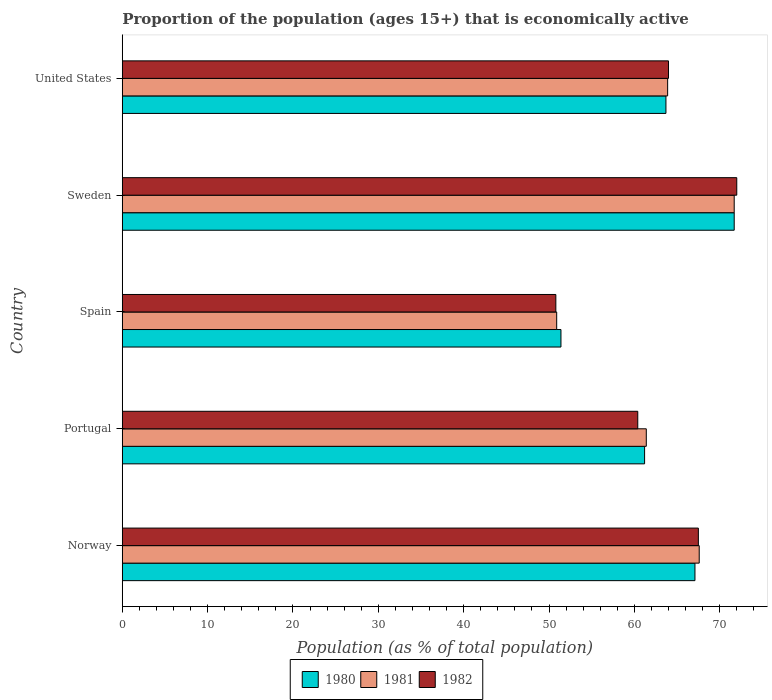How many groups of bars are there?
Your response must be concise. 5. Are the number of bars per tick equal to the number of legend labels?
Ensure brevity in your answer.  Yes. Are the number of bars on each tick of the Y-axis equal?
Your answer should be very brief. Yes. How many bars are there on the 3rd tick from the bottom?
Offer a terse response. 3. What is the label of the 5th group of bars from the top?
Ensure brevity in your answer.  Norway. In how many cases, is the number of bars for a given country not equal to the number of legend labels?
Offer a very short reply. 0. Across all countries, what is the minimum proportion of the population that is economically active in 1982?
Keep it short and to the point. 50.8. In which country was the proportion of the population that is economically active in 1981 maximum?
Keep it short and to the point. Sweden. What is the total proportion of the population that is economically active in 1980 in the graph?
Your answer should be compact. 315.1. What is the difference between the proportion of the population that is economically active in 1981 in Portugal and that in Spain?
Offer a terse response. 10.5. What is the difference between the proportion of the population that is economically active in 1980 in Norway and the proportion of the population that is economically active in 1982 in Portugal?
Your answer should be very brief. 6.7. What is the average proportion of the population that is economically active in 1982 per country?
Your answer should be compact. 62.94. What is the difference between the proportion of the population that is economically active in 1982 and proportion of the population that is economically active in 1981 in Sweden?
Offer a terse response. 0.3. In how many countries, is the proportion of the population that is economically active in 1981 greater than 38 %?
Make the answer very short. 5. What is the ratio of the proportion of the population that is economically active in 1982 in Norway to that in United States?
Offer a very short reply. 1.05. Is the proportion of the population that is economically active in 1982 in Norway less than that in Sweden?
Give a very brief answer. Yes. Is the difference between the proportion of the population that is economically active in 1982 in Norway and United States greater than the difference between the proportion of the population that is economically active in 1981 in Norway and United States?
Your answer should be compact. No. What is the difference between the highest and the second highest proportion of the population that is economically active in 1982?
Give a very brief answer. 4.5. What is the difference between the highest and the lowest proportion of the population that is economically active in 1982?
Your answer should be very brief. 21.2. What does the 2nd bar from the top in Portugal represents?
Make the answer very short. 1981. How many bars are there?
Provide a short and direct response. 15. What is the difference between two consecutive major ticks on the X-axis?
Your answer should be compact. 10. Does the graph contain grids?
Provide a short and direct response. No. Where does the legend appear in the graph?
Your response must be concise. Bottom center. What is the title of the graph?
Keep it short and to the point. Proportion of the population (ages 15+) that is economically active. Does "1974" appear as one of the legend labels in the graph?
Provide a short and direct response. No. What is the label or title of the X-axis?
Your answer should be compact. Population (as % of total population). What is the Population (as % of total population) of 1980 in Norway?
Provide a succinct answer. 67.1. What is the Population (as % of total population) of 1981 in Norway?
Give a very brief answer. 67.6. What is the Population (as % of total population) of 1982 in Norway?
Give a very brief answer. 67.5. What is the Population (as % of total population) in 1980 in Portugal?
Offer a very short reply. 61.2. What is the Population (as % of total population) of 1981 in Portugal?
Your answer should be compact. 61.4. What is the Population (as % of total population) in 1982 in Portugal?
Provide a short and direct response. 60.4. What is the Population (as % of total population) of 1980 in Spain?
Give a very brief answer. 51.4. What is the Population (as % of total population) of 1981 in Spain?
Provide a succinct answer. 50.9. What is the Population (as % of total population) of 1982 in Spain?
Make the answer very short. 50.8. What is the Population (as % of total population) in 1980 in Sweden?
Offer a very short reply. 71.7. What is the Population (as % of total population) of 1981 in Sweden?
Offer a very short reply. 71.7. What is the Population (as % of total population) in 1982 in Sweden?
Offer a very short reply. 72. What is the Population (as % of total population) in 1980 in United States?
Your answer should be very brief. 63.7. What is the Population (as % of total population) in 1981 in United States?
Make the answer very short. 63.9. What is the Population (as % of total population) of 1982 in United States?
Ensure brevity in your answer.  64. Across all countries, what is the maximum Population (as % of total population) of 1980?
Offer a terse response. 71.7. Across all countries, what is the maximum Population (as % of total population) of 1981?
Offer a terse response. 71.7. Across all countries, what is the maximum Population (as % of total population) of 1982?
Provide a succinct answer. 72. Across all countries, what is the minimum Population (as % of total population) in 1980?
Give a very brief answer. 51.4. Across all countries, what is the minimum Population (as % of total population) in 1981?
Keep it short and to the point. 50.9. Across all countries, what is the minimum Population (as % of total population) in 1982?
Your answer should be very brief. 50.8. What is the total Population (as % of total population) of 1980 in the graph?
Offer a terse response. 315.1. What is the total Population (as % of total population) in 1981 in the graph?
Offer a very short reply. 315.5. What is the total Population (as % of total population) in 1982 in the graph?
Your response must be concise. 314.7. What is the difference between the Population (as % of total population) in 1982 in Norway and that in Portugal?
Provide a short and direct response. 7.1. What is the difference between the Population (as % of total population) of 1980 in Norway and that in Spain?
Provide a succinct answer. 15.7. What is the difference between the Population (as % of total population) of 1981 in Norway and that in Spain?
Ensure brevity in your answer.  16.7. What is the difference between the Population (as % of total population) of 1981 in Norway and that in United States?
Offer a very short reply. 3.7. What is the difference between the Population (as % of total population) in 1981 in Portugal and that in Spain?
Give a very brief answer. 10.5. What is the difference between the Population (as % of total population) in 1982 in Portugal and that in Spain?
Make the answer very short. 9.6. What is the difference between the Population (as % of total population) in 1980 in Portugal and that in Sweden?
Ensure brevity in your answer.  -10.5. What is the difference between the Population (as % of total population) in 1981 in Portugal and that in United States?
Offer a very short reply. -2.5. What is the difference between the Population (as % of total population) in 1982 in Portugal and that in United States?
Your response must be concise. -3.6. What is the difference between the Population (as % of total population) of 1980 in Spain and that in Sweden?
Make the answer very short. -20.3. What is the difference between the Population (as % of total population) of 1981 in Spain and that in Sweden?
Make the answer very short. -20.8. What is the difference between the Population (as % of total population) of 1982 in Spain and that in Sweden?
Your answer should be very brief. -21.2. What is the difference between the Population (as % of total population) of 1980 in Spain and that in United States?
Your response must be concise. -12.3. What is the difference between the Population (as % of total population) in 1980 in Sweden and that in United States?
Make the answer very short. 8. What is the difference between the Population (as % of total population) of 1981 in Sweden and that in United States?
Ensure brevity in your answer.  7.8. What is the difference between the Population (as % of total population) in 1982 in Sweden and that in United States?
Give a very brief answer. 8. What is the difference between the Population (as % of total population) in 1980 in Norway and the Population (as % of total population) in 1982 in Portugal?
Your answer should be compact. 6.7. What is the difference between the Population (as % of total population) of 1981 in Norway and the Population (as % of total population) of 1982 in Portugal?
Provide a succinct answer. 7.2. What is the difference between the Population (as % of total population) in 1980 in Norway and the Population (as % of total population) in 1982 in Sweden?
Make the answer very short. -4.9. What is the difference between the Population (as % of total population) of 1980 in Norway and the Population (as % of total population) of 1981 in United States?
Make the answer very short. 3.2. What is the difference between the Population (as % of total population) of 1981 in Norway and the Population (as % of total population) of 1982 in United States?
Ensure brevity in your answer.  3.6. What is the difference between the Population (as % of total population) in 1980 in Portugal and the Population (as % of total population) in 1981 in Spain?
Provide a short and direct response. 10.3. What is the difference between the Population (as % of total population) in 1980 in Portugal and the Population (as % of total population) in 1982 in Spain?
Offer a very short reply. 10.4. What is the difference between the Population (as % of total population) of 1980 in Portugal and the Population (as % of total population) of 1982 in Sweden?
Keep it short and to the point. -10.8. What is the difference between the Population (as % of total population) of 1980 in Portugal and the Population (as % of total population) of 1982 in United States?
Offer a terse response. -2.8. What is the difference between the Population (as % of total population) of 1981 in Portugal and the Population (as % of total population) of 1982 in United States?
Offer a very short reply. -2.6. What is the difference between the Population (as % of total population) in 1980 in Spain and the Population (as % of total population) in 1981 in Sweden?
Offer a terse response. -20.3. What is the difference between the Population (as % of total population) in 1980 in Spain and the Population (as % of total population) in 1982 in Sweden?
Provide a succinct answer. -20.6. What is the difference between the Population (as % of total population) in 1981 in Spain and the Population (as % of total population) in 1982 in Sweden?
Offer a terse response. -21.1. What is the difference between the Population (as % of total population) in 1981 in Spain and the Population (as % of total population) in 1982 in United States?
Your answer should be compact. -13.1. What is the average Population (as % of total population) of 1980 per country?
Ensure brevity in your answer.  63.02. What is the average Population (as % of total population) of 1981 per country?
Offer a terse response. 63.1. What is the average Population (as % of total population) in 1982 per country?
Offer a terse response. 62.94. What is the difference between the Population (as % of total population) of 1980 and Population (as % of total population) of 1982 in Norway?
Make the answer very short. -0.4. What is the difference between the Population (as % of total population) in 1981 and Population (as % of total population) in 1982 in Norway?
Keep it short and to the point. 0.1. What is the difference between the Population (as % of total population) of 1980 and Population (as % of total population) of 1981 in Spain?
Your answer should be very brief. 0.5. What is the difference between the Population (as % of total population) of 1980 and Population (as % of total population) of 1982 in Spain?
Provide a succinct answer. 0.6. What is the difference between the Population (as % of total population) in 1980 and Population (as % of total population) in 1982 in Sweden?
Your answer should be very brief. -0.3. What is the difference between the Population (as % of total population) of 1980 and Population (as % of total population) of 1981 in United States?
Your answer should be compact. -0.2. What is the difference between the Population (as % of total population) of 1980 and Population (as % of total population) of 1982 in United States?
Your response must be concise. -0.3. What is the ratio of the Population (as % of total population) in 1980 in Norway to that in Portugal?
Offer a terse response. 1.1. What is the ratio of the Population (as % of total population) in 1981 in Norway to that in Portugal?
Offer a terse response. 1.1. What is the ratio of the Population (as % of total population) in 1982 in Norway to that in Portugal?
Give a very brief answer. 1.12. What is the ratio of the Population (as % of total population) in 1980 in Norway to that in Spain?
Offer a terse response. 1.31. What is the ratio of the Population (as % of total population) of 1981 in Norway to that in Spain?
Give a very brief answer. 1.33. What is the ratio of the Population (as % of total population) of 1982 in Norway to that in Spain?
Your answer should be compact. 1.33. What is the ratio of the Population (as % of total population) in 1980 in Norway to that in Sweden?
Give a very brief answer. 0.94. What is the ratio of the Population (as % of total population) of 1981 in Norway to that in Sweden?
Your answer should be very brief. 0.94. What is the ratio of the Population (as % of total population) in 1982 in Norway to that in Sweden?
Your response must be concise. 0.94. What is the ratio of the Population (as % of total population) of 1980 in Norway to that in United States?
Your response must be concise. 1.05. What is the ratio of the Population (as % of total population) of 1981 in Norway to that in United States?
Your answer should be compact. 1.06. What is the ratio of the Population (as % of total population) in 1982 in Norway to that in United States?
Keep it short and to the point. 1.05. What is the ratio of the Population (as % of total population) in 1980 in Portugal to that in Spain?
Your answer should be very brief. 1.19. What is the ratio of the Population (as % of total population) in 1981 in Portugal to that in Spain?
Offer a very short reply. 1.21. What is the ratio of the Population (as % of total population) of 1982 in Portugal to that in Spain?
Offer a terse response. 1.19. What is the ratio of the Population (as % of total population) of 1980 in Portugal to that in Sweden?
Your answer should be compact. 0.85. What is the ratio of the Population (as % of total population) of 1981 in Portugal to that in Sweden?
Ensure brevity in your answer.  0.86. What is the ratio of the Population (as % of total population) in 1982 in Portugal to that in Sweden?
Keep it short and to the point. 0.84. What is the ratio of the Population (as % of total population) of 1980 in Portugal to that in United States?
Make the answer very short. 0.96. What is the ratio of the Population (as % of total population) in 1981 in Portugal to that in United States?
Provide a short and direct response. 0.96. What is the ratio of the Population (as % of total population) in 1982 in Portugal to that in United States?
Make the answer very short. 0.94. What is the ratio of the Population (as % of total population) of 1980 in Spain to that in Sweden?
Provide a succinct answer. 0.72. What is the ratio of the Population (as % of total population) in 1981 in Spain to that in Sweden?
Provide a short and direct response. 0.71. What is the ratio of the Population (as % of total population) in 1982 in Spain to that in Sweden?
Ensure brevity in your answer.  0.71. What is the ratio of the Population (as % of total population) in 1980 in Spain to that in United States?
Provide a succinct answer. 0.81. What is the ratio of the Population (as % of total population) in 1981 in Spain to that in United States?
Your answer should be compact. 0.8. What is the ratio of the Population (as % of total population) of 1982 in Spain to that in United States?
Make the answer very short. 0.79. What is the ratio of the Population (as % of total population) in 1980 in Sweden to that in United States?
Your response must be concise. 1.13. What is the ratio of the Population (as % of total population) of 1981 in Sweden to that in United States?
Give a very brief answer. 1.12. What is the ratio of the Population (as % of total population) in 1982 in Sweden to that in United States?
Ensure brevity in your answer.  1.12. What is the difference between the highest and the second highest Population (as % of total population) in 1980?
Your response must be concise. 4.6. What is the difference between the highest and the second highest Population (as % of total population) in 1982?
Make the answer very short. 4.5. What is the difference between the highest and the lowest Population (as % of total population) of 1980?
Ensure brevity in your answer.  20.3. What is the difference between the highest and the lowest Population (as % of total population) in 1981?
Keep it short and to the point. 20.8. What is the difference between the highest and the lowest Population (as % of total population) in 1982?
Ensure brevity in your answer.  21.2. 